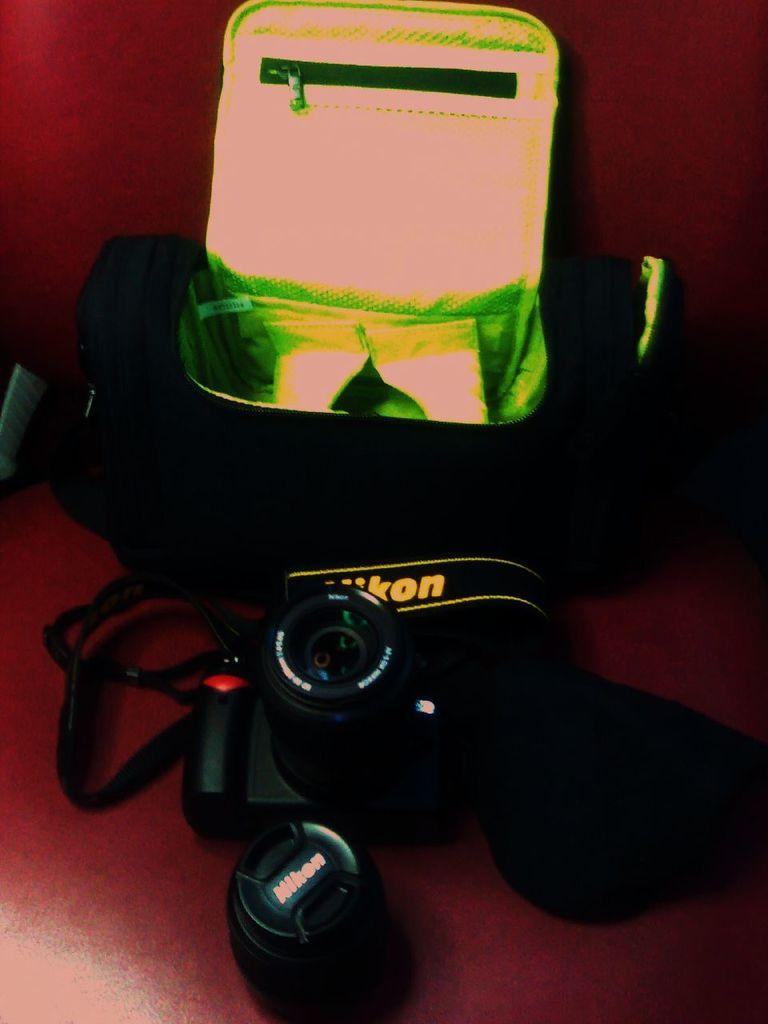What objects can be seen in the image? There are bags in the image. What color is the background of the image? The background of the image is maroon. How many branches can be seen growing from the bags in the image? There are no branches visible in the image, as it features bags and a maroon background. 